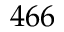<formula> <loc_0><loc_0><loc_500><loc_500>4 6 6</formula> 